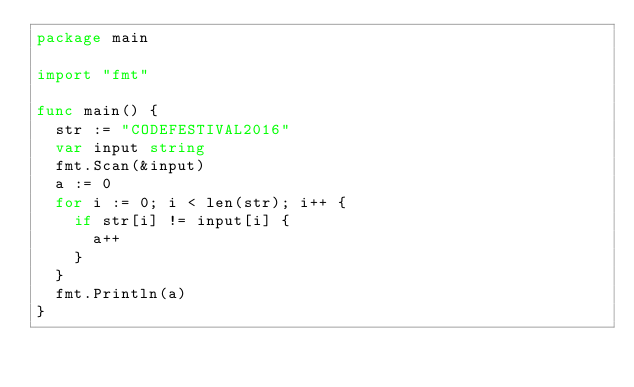<code> <loc_0><loc_0><loc_500><loc_500><_Go_>package main

import "fmt"

func main() {
	str := "CODEFESTIVAL2016"
	var input string
	fmt.Scan(&input)
	a := 0
	for i := 0; i < len(str); i++ {
		if str[i] != input[i] {
			a++
		}
	}
	fmt.Println(a)
}</code> 